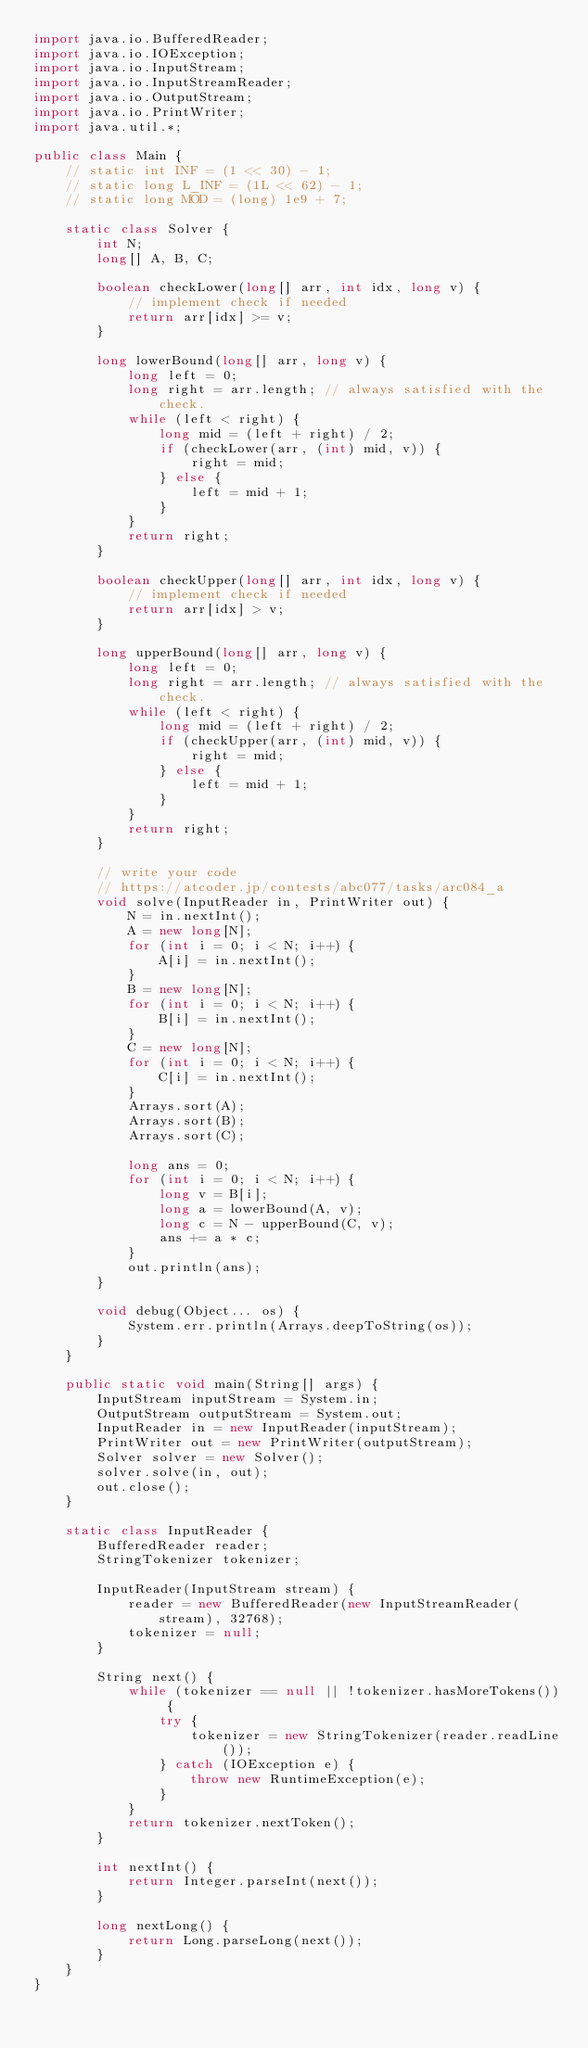<code> <loc_0><loc_0><loc_500><loc_500><_Java_>import java.io.BufferedReader;
import java.io.IOException;
import java.io.InputStream;
import java.io.InputStreamReader;
import java.io.OutputStream;
import java.io.PrintWriter;
import java.util.*;

public class Main {
    // static int INF = (1 << 30) - 1;
    // static long L_INF = (1L << 62) - 1;
    // static long MOD = (long) 1e9 + 7;

    static class Solver {
        int N;
        long[] A, B, C;

        boolean checkLower(long[] arr, int idx, long v) {
            // implement check if needed
            return arr[idx] >= v;
        }

        long lowerBound(long[] arr, long v) {
            long left = 0;
            long right = arr.length; // always satisfied with the check.
            while (left < right) {
                long mid = (left + right) / 2;
                if (checkLower(arr, (int) mid, v)) {
                    right = mid;
                } else {
                    left = mid + 1;
                }
            }
            return right;
        }

        boolean checkUpper(long[] arr, int idx, long v) {
            // implement check if needed
            return arr[idx] > v;
        }

        long upperBound(long[] arr, long v) {
            long left = 0;
            long right = arr.length; // always satisfied with the check.
            while (left < right) {
                long mid = (left + right) / 2;
                if (checkUpper(arr, (int) mid, v)) {
                    right = mid;
                } else {
                    left = mid + 1;
                }
            }
            return right;
        }

        // write your code
        // https://atcoder.jp/contests/abc077/tasks/arc084_a
        void solve(InputReader in, PrintWriter out) {
            N = in.nextInt();
            A = new long[N];
            for (int i = 0; i < N; i++) {
                A[i] = in.nextInt();
            }
            B = new long[N];
            for (int i = 0; i < N; i++) {
                B[i] = in.nextInt();
            }
            C = new long[N];
            for (int i = 0; i < N; i++) {
                C[i] = in.nextInt();
            }
            Arrays.sort(A);
            Arrays.sort(B);
            Arrays.sort(C);

            long ans = 0;
            for (int i = 0; i < N; i++) {
                long v = B[i];
                long a = lowerBound(A, v);
                long c = N - upperBound(C, v);
                ans += a * c;
            }
            out.println(ans);
        }

        void debug(Object... os) {
            System.err.println(Arrays.deepToString(os));
        }
    }

    public static void main(String[] args) {
        InputStream inputStream = System.in;
        OutputStream outputStream = System.out;
        InputReader in = new InputReader(inputStream);
        PrintWriter out = new PrintWriter(outputStream);
        Solver solver = new Solver();
        solver.solve(in, out);
        out.close();
    }

    static class InputReader {
        BufferedReader reader;
        StringTokenizer tokenizer;

        InputReader(InputStream stream) {
            reader = new BufferedReader(new InputStreamReader(stream), 32768);
            tokenizer = null;
        }

        String next() {
            while (tokenizer == null || !tokenizer.hasMoreTokens()) {
                try {
                    tokenizer = new StringTokenizer(reader.readLine());
                } catch (IOException e) {
                    throw new RuntimeException(e);
                }
            }
            return tokenizer.nextToken();
        }

        int nextInt() {
            return Integer.parseInt(next());
        }

        long nextLong() {
            return Long.parseLong(next());
        }
    }
}
</code> 